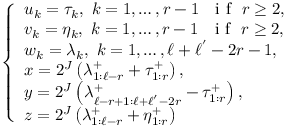Convert formula to latex. <formula><loc_0><loc_0><loc_500><loc_500>\begin{array} { r } { \left \{ \begin{array} { l } { u _ { k } = \tau _ { k } , \ k = 1 , \dots , r - 1 \ \ i f \ r \geq 2 , } \\ { v _ { k } = \eta _ { k } , \ k = 1 , \dots , r - 1 \ \ i f \ r \geq 2 , } \\ { w _ { k } = \lambda _ { k } , \ k = 1 , \dots , \ell + \ell ^ { ^ { \prime } } - 2 r - 1 , } \\ { x = 2 ^ { J } \left ( \lambda _ { 1 \colon \ell - r } ^ { + } + \tau _ { 1 \colon r } ^ { + } \right ) , } \\ { y = 2 ^ { J } \left ( \lambda _ { \ell - r + 1 \colon \ell + \ell ^ { ^ { \prime } } - 2 r } ^ { + } - \tau _ { 1 \colon r } ^ { + } \right ) , } \\ { z = 2 ^ { J } \left ( \lambda _ { 1 \colon \ell - r } ^ { + } + \eta _ { 1 \colon r } ^ { + } \right ) } \end{array} } \end{array}</formula> 